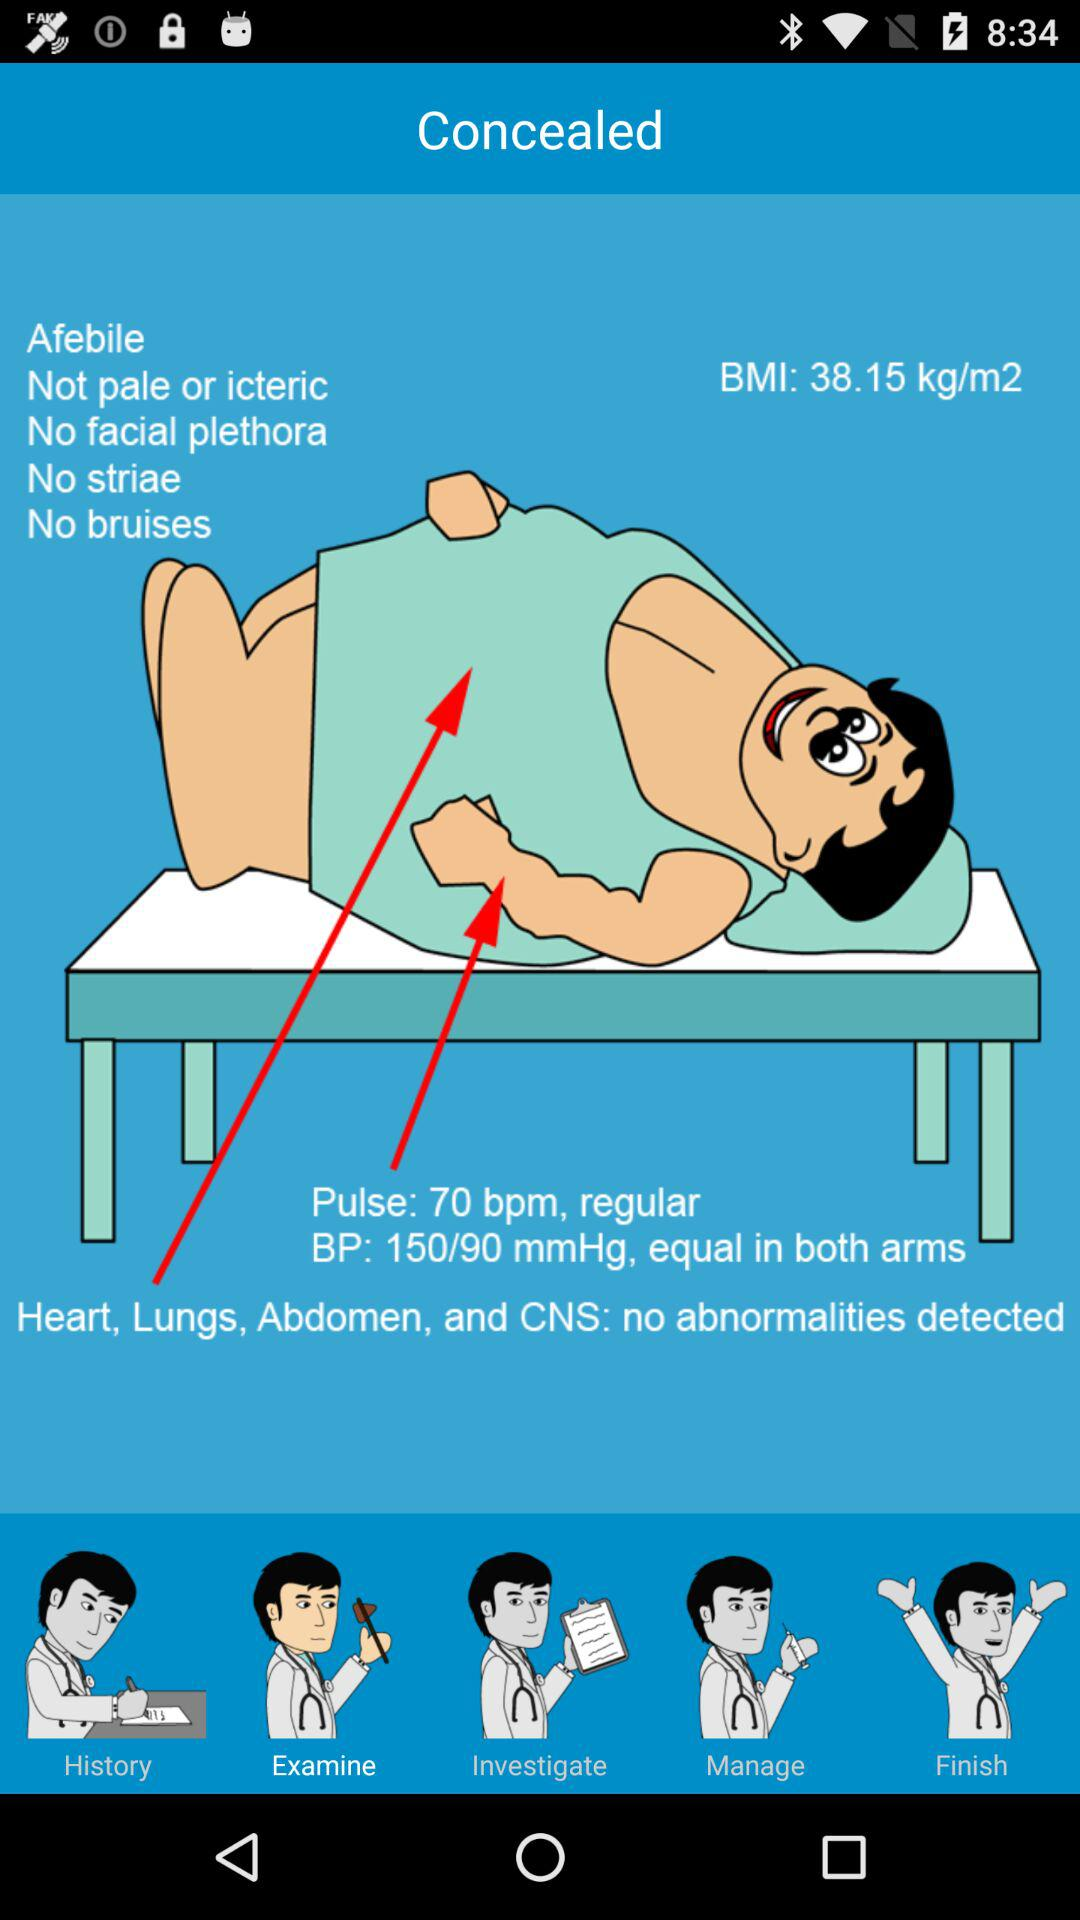What is the BMI? The BMI is 38.15 kg/m2. 